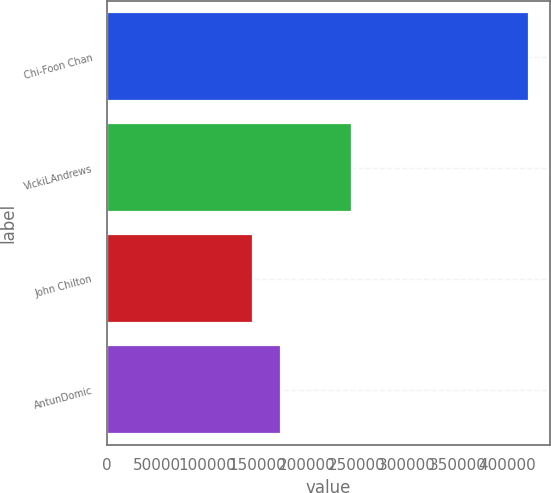<chart> <loc_0><loc_0><loc_500><loc_500><bar_chart><fcel>Chi-Foon Chan<fcel>VickiLAndrews<fcel>John Chilton<fcel>AntunDomic<nl><fcel>421372<fcel>244853<fcel>146232<fcel>173815<nl></chart> 